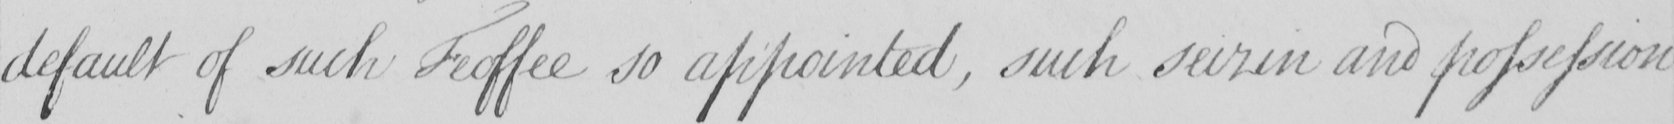Can you read and transcribe this handwriting? default of such Feoffee so appointed , such seizin and possession 